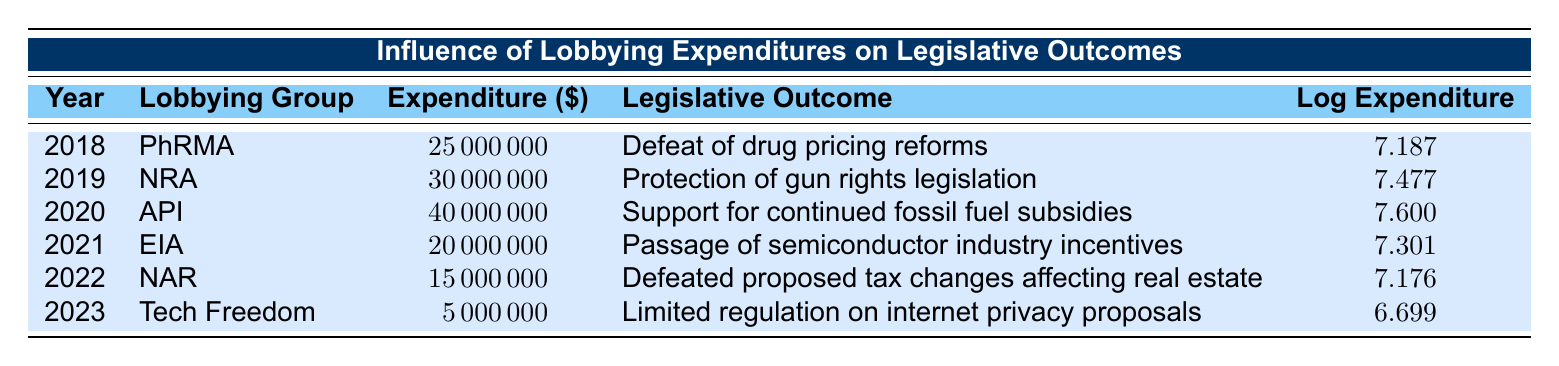What was the lobbying expenditure of the National Rifle Association (NRA) in 2019? The table shows that the NRA had an expenditure of 30,000,000 in 2019.
Answer: 30,000,000 Which lobbying group had the highest expenditure in the given years? By examining the expenditures, the American Petroleum Institute (API) in 2020 had the highest expenditure of 40,000,000.
Answer: American Petroleum Institute (API) What was the total lobbying expenditure from 2018 to 2022? To find the total, add up the expenditures: 25,000,000 + 30,000,000 + 40,000,000 + 20,000,000 + 15,000,000 = 130,000,000.
Answer: 130,000,000 Did the Tech Freedom group spend more than 10 million in 2023? The table lists the expenditure for Tech Freedom in 2023 as 5,000,000, which is less than 10,000,000.
Answer: No What is the average lobbying expenditure for the years 2018 to 2023? First, sum the expenditures: 25,000,000 + 30,000,000 + 40,000,000 + 20,000,000 + 15,000,000 + 5,000,000 = 135,000,000. Then divide by the number of years, which is 6: 135,000,000 / 6 = 22,500,000.
Answer: 22,500,000 Which year had the lowest lobbying expenditure and what was that amount? The lowest expenditure is from Tech Freedom in 2023 at 5,000,000.
Answer: 5,000,000 Were there any lobbying groups that influenced legislative outcomes related to gun rights? Yes, the NRA in 2019 influenced the protection of gun rights legislation.
Answer: Yes How many different lobbying groups are represented in the table? There are six unique lobbying groups listed: PhRMA, NRA, API, EIA, NAR, and Tech Freedom.
Answer: 6 